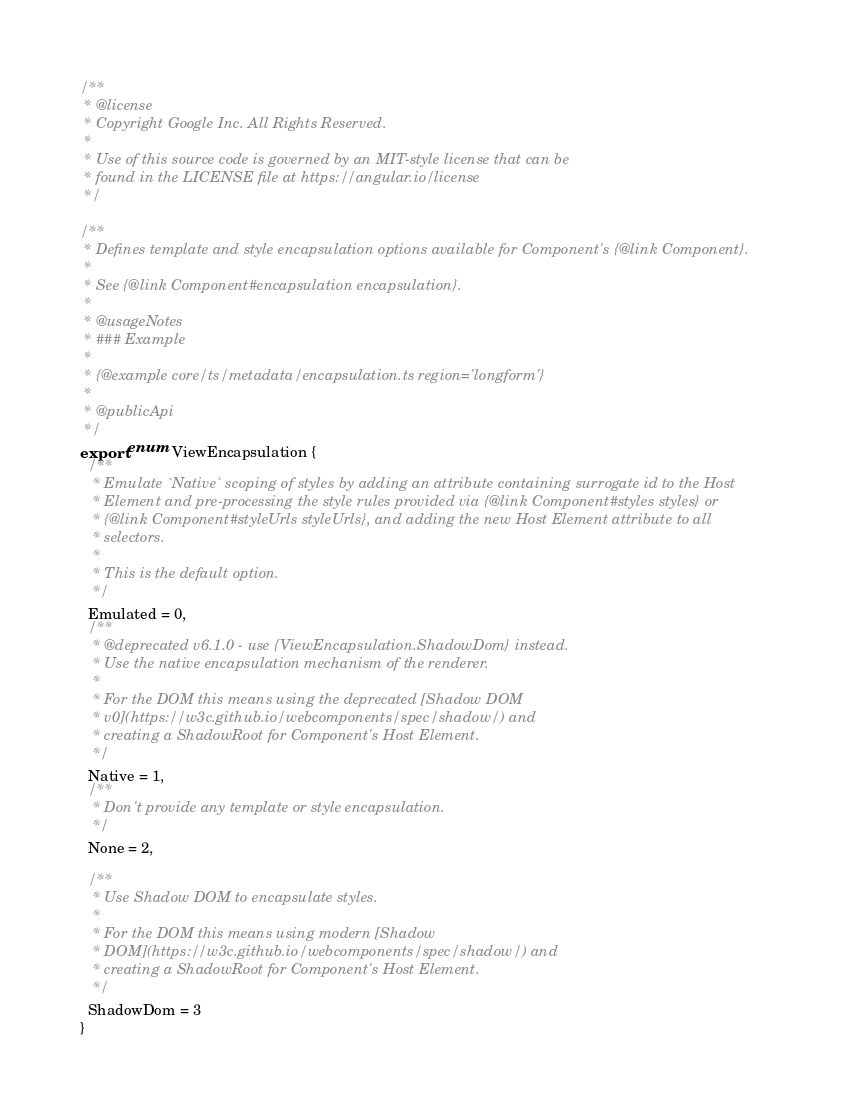Convert code to text. <code><loc_0><loc_0><loc_500><loc_500><_TypeScript_>/**
 * @license
 * Copyright Google Inc. All Rights Reserved.
 *
 * Use of this source code is governed by an MIT-style license that can be
 * found in the LICENSE file at https://angular.io/license
 */

/**
 * Defines template and style encapsulation options available for Component's {@link Component}.
 *
 * See {@link Component#encapsulation encapsulation}.
 *
 * @usageNotes
 * ### Example
 *
 * {@example core/ts/metadata/encapsulation.ts region='longform'}
 *
 * @publicApi
 */
export enum ViewEncapsulation {
  /**
   * Emulate `Native` scoping of styles by adding an attribute containing surrogate id to the Host
   * Element and pre-processing the style rules provided via {@link Component#styles styles} or
   * {@link Component#styleUrls styleUrls}, and adding the new Host Element attribute to all
   * selectors.
   *
   * This is the default option.
   */
  Emulated = 0,
  /**
   * @deprecated v6.1.0 - use {ViewEncapsulation.ShadowDom} instead.
   * Use the native encapsulation mechanism of the renderer.
   *
   * For the DOM this means using the deprecated [Shadow DOM
   * v0](https://w3c.github.io/webcomponents/spec/shadow/) and
   * creating a ShadowRoot for Component's Host Element.
   */
  Native = 1,
  /**
   * Don't provide any template or style encapsulation.
   */
  None = 2,

  /**
   * Use Shadow DOM to encapsulate styles.
   *
   * For the DOM this means using modern [Shadow
   * DOM](https://w3c.github.io/webcomponents/spec/shadow/) and
   * creating a ShadowRoot for Component's Host Element.
   */
  ShadowDom = 3
}
</code> 